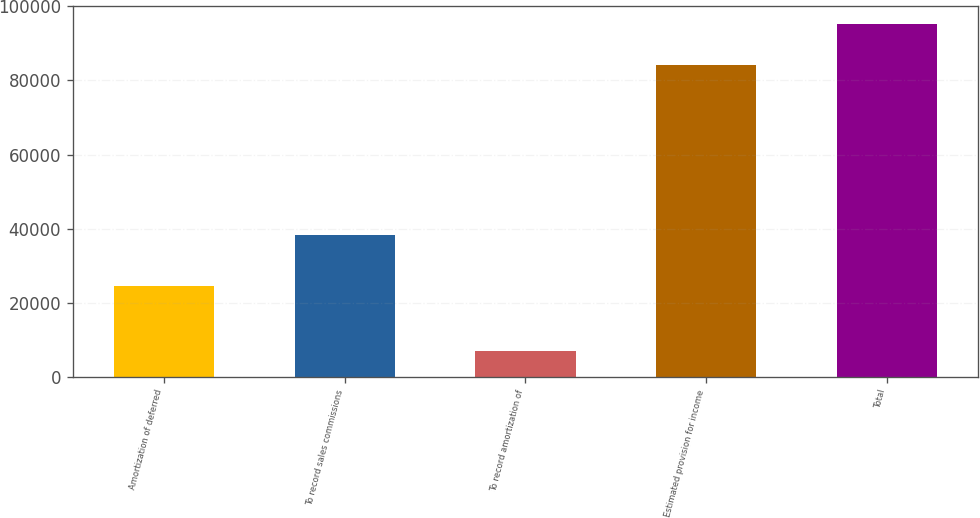Convert chart. <chart><loc_0><loc_0><loc_500><loc_500><bar_chart><fcel>Amortization of deferred<fcel>To record sales commissions<fcel>To record amortization of<fcel>Estimated provision for income<fcel>Total<nl><fcel>24661.2<fcel>38352<fcel>7000<fcel>84106<fcel>95306<nl></chart> 